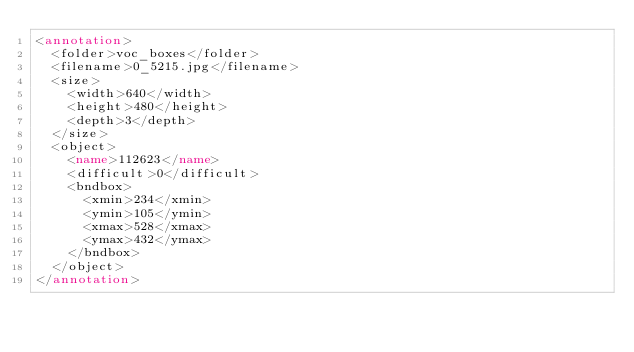<code> <loc_0><loc_0><loc_500><loc_500><_XML_><annotation>
  <folder>voc_boxes</folder>
  <filename>0_5215.jpg</filename>
  <size>
    <width>640</width>
    <height>480</height>
    <depth>3</depth>
  </size>
  <object>
    <name>112623</name>
    <difficult>0</difficult>
    <bndbox>
      <xmin>234</xmin>
      <ymin>105</ymin>
      <xmax>528</xmax>
      <ymax>432</ymax>
    </bndbox>
  </object>
</annotation></code> 